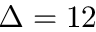<formula> <loc_0><loc_0><loc_500><loc_500>\Delta = 1 2</formula> 